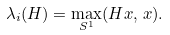<formula> <loc_0><loc_0><loc_500><loc_500>\lambda _ { i } ( H ) = \max _ { S ^ { 1 } } ( H x , \, x ) .</formula> 